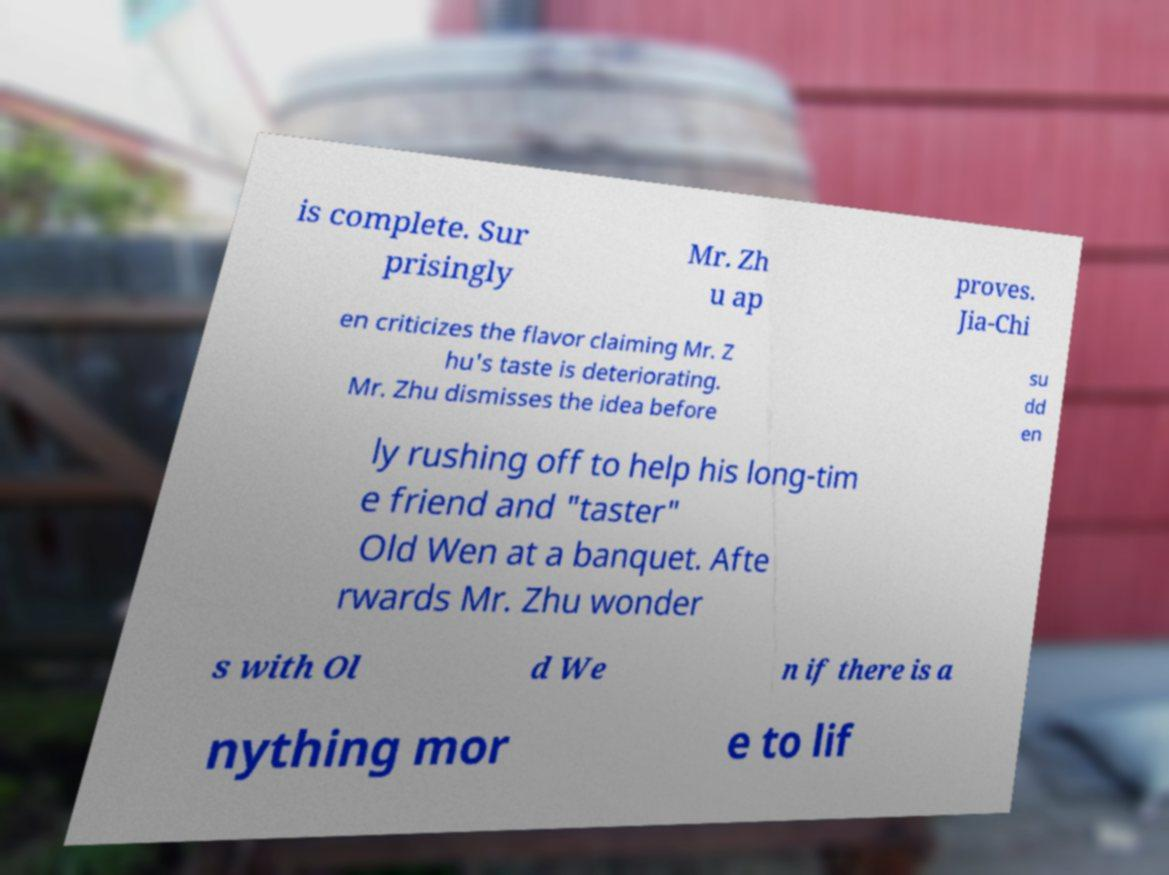Could you extract and type out the text from this image? is complete. Sur prisingly Mr. Zh u ap proves. Jia-Chi en criticizes the flavor claiming Mr. Z hu's taste is deteriorating. Mr. Zhu dismisses the idea before su dd en ly rushing off to help his long-tim e friend and "taster" Old Wen at a banquet. Afte rwards Mr. Zhu wonder s with Ol d We n if there is a nything mor e to lif 